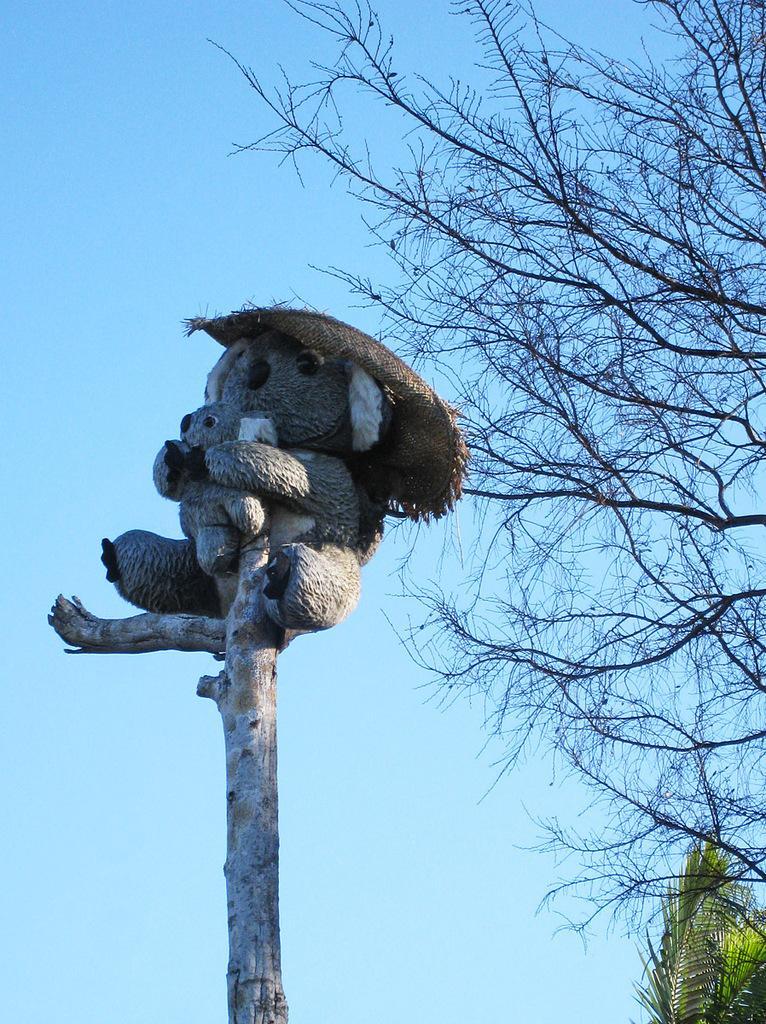How would you summarize this image in a sentence or two? In this image we can see the wood, on the wood we can see a teddy bear, there are some trees and in the background we can see the sky. 